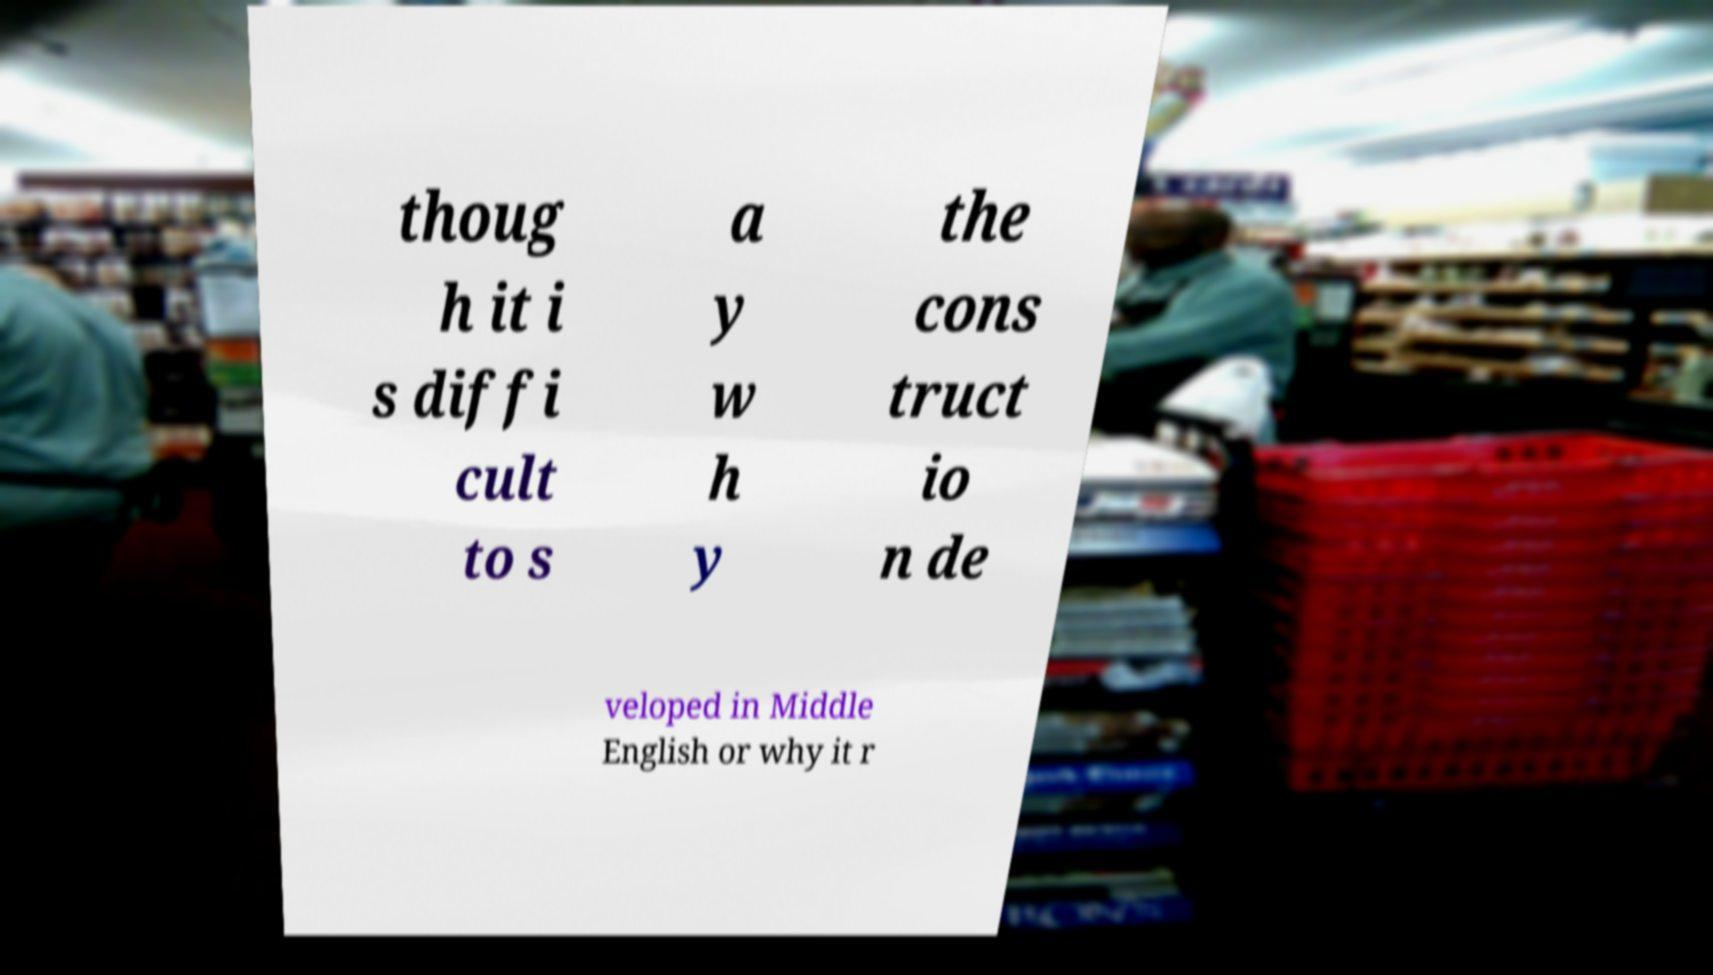Could you extract and type out the text from this image? thoug h it i s diffi cult to s a y w h y the cons truct io n de veloped in Middle English or why it r 